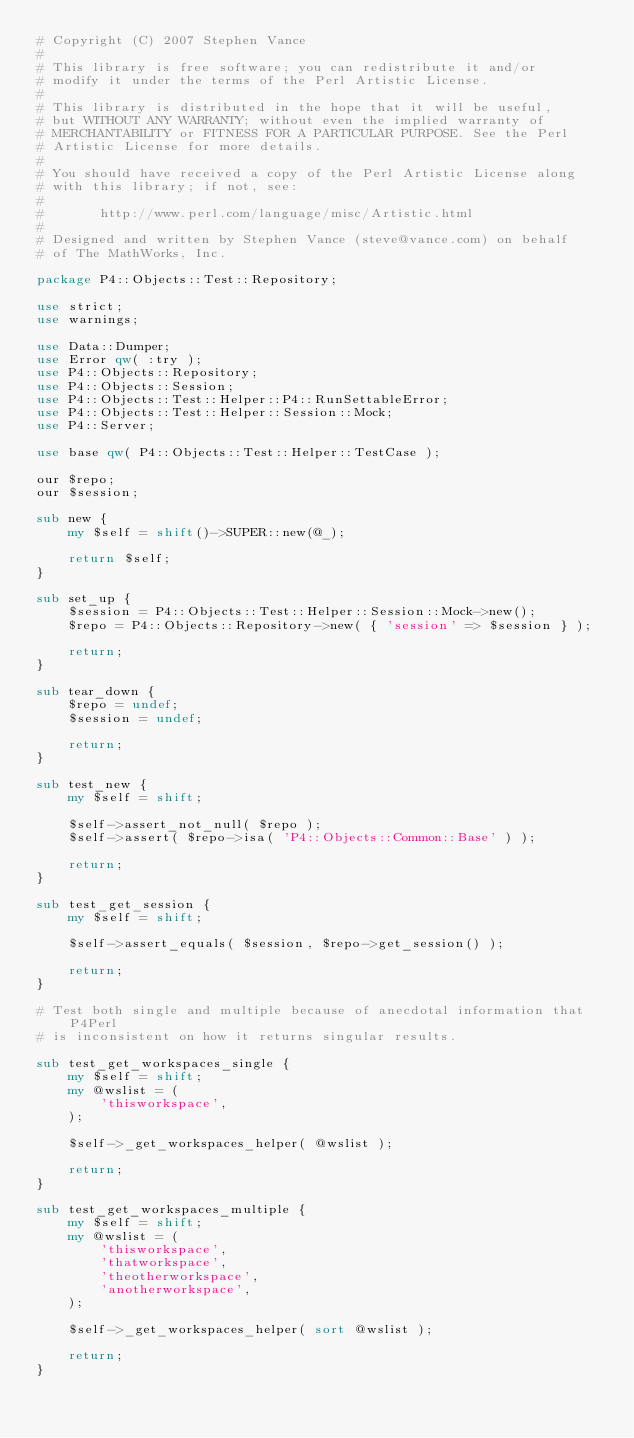<code> <loc_0><loc_0><loc_500><loc_500><_Perl_># Copyright (C) 2007 Stephen Vance
# 
# This library is free software; you can redistribute it and/or
# modify it under the terms of the Perl Artistic License.
# 
# This library is distributed in the hope that it will be useful,
# but WITHOUT ANY WARRANTY; without even the implied warranty of
# MERCHANTABILITY or FITNESS FOR A PARTICULAR PURPOSE. See the Perl
# Artistic License for more details.
# 
# You should have received a copy of the Perl Artistic License along
# with this library; if not, see:
#
#       http://www.perl.com/language/misc/Artistic.html
# 
# Designed and written by Stephen Vance (steve@vance.com) on behalf
# of The MathWorks, Inc.

package P4::Objects::Test::Repository;

use strict;
use warnings;

use Data::Dumper;
use Error qw( :try );
use P4::Objects::Repository;
use P4::Objects::Session;
use P4::Objects::Test::Helper::P4::RunSettableError;
use P4::Objects::Test::Helper::Session::Mock;
use P4::Server;

use base qw( P4::Objects::Test::Helper::TestCase );

our $repo;
our $session;

sub new {
    my $self = shift()->SUPER::new(@_);

    return $self;
}

sub set_up {
    $session = P4::Objects::Test::Helper::Session::Mock->new();
    $repo = P4::Objects::Repository->new( { 'session' => $session } );

    return;
}

sub tear_down {
    $repo = undef;
    $session = undef;

    return;
}

sub test_new {
    my $self = shift;

    $self->assert_not_null( $repo );
    $self->assert( $repo->isa( 'P4::Objects::Common::Base' ) );

    return;
}

sub test_get_session {
    my $self = shift;

    $self->assert_equals( $session, $repo->get_session() );

    return;
}

# Test both single and multiple because of anecdotal information that P4Perl
# is inconsistent on how it returns singular results.

sub test_get_workspaces_single {
    my $self = shift;
    my @wslist = (
        'thisworkspace',
    );

    $self->_get_workspaces_helper( @wslist );

    return;
}

sub test_get_workspaces_multiple {
    my $self = shift;
    my @wslist = (
        'thisworkspace',
        'thatworkspace',
        'theotherworkspace',
        'anotherworkspace',
    );

    $self->_get_workspaces_helper( sort @wslist );

    return;
}
</code> 